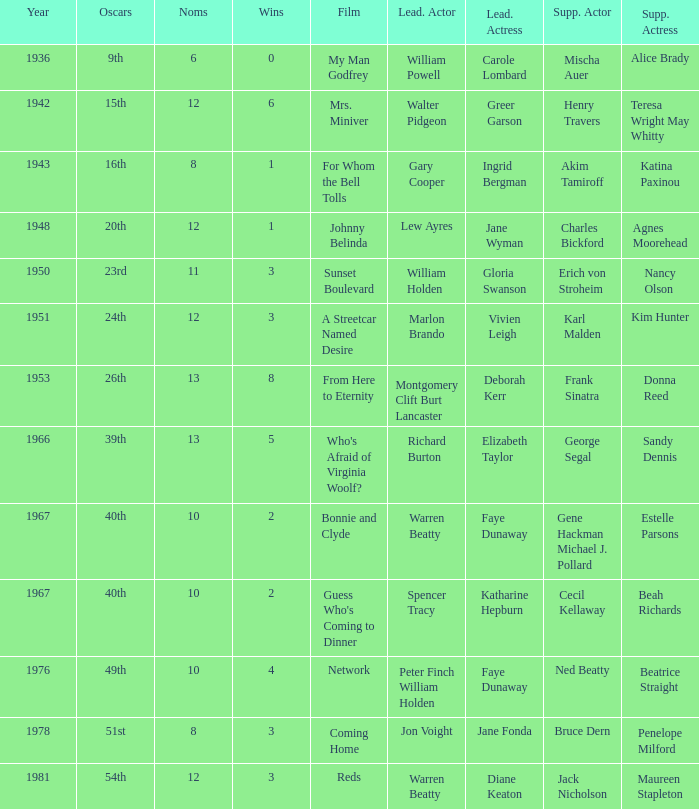Who was the supporting actress in "For Whom the Bell Tolls"? Katina Paxinou. 